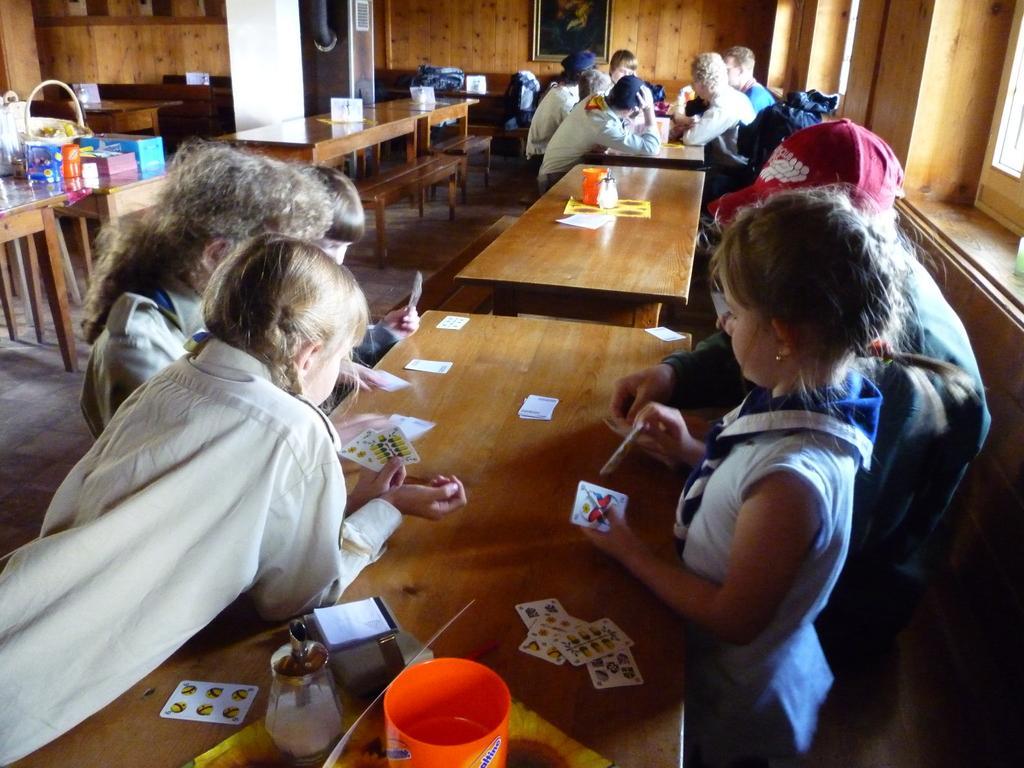Could you give a brief overview of what you see in this image? In the image, there are many tables and benches, on the first table there are four people sitting they are playing cards, to the left side on the table there are some snacks, in the background there is a wooden wall and a photo frame to the wall. 